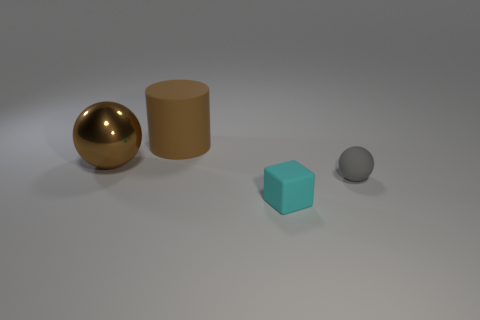Are there any other things that are made of the same material as the big ball?
Offer a very short reply. No. The object that is the same color as the big metallic sphere is what shape?
Your answer should be compact. Cylinder. There is a sphere that is left of the ball right of the brown metal ball; is there a large brown rubber cylinder that is in front of it?
Make the answer very short. No. Do the cyan rubber object and the metal ball have the same size?
Your response must be concise. No. Is the number of tiny cyan objects that are behind the small gray matte thing the same as the number of small cyan objects that are on the right side of the rubber cube?
Provide a short and direct response. Yes. There is a matte object behind the tiny gray thing; what shape is it?
Make the answer very short. Cylinder. The matte object that is the same size as the block is what shape?
Your answer should be very brief. Sphere. What is the color of the rubber thing left of the tiny rubber object in front of the tiny object behind the cyan matte thing?
Provide a short and direct response. Brown. Do the big brown matte object and the brown metallic thing have the same shape?
Keep it short and to the point. No. Are there an equal number of tiny rubber spheres that are behind the brown metallic ball and large matte cylinders?
Your answer should be compact. No. 